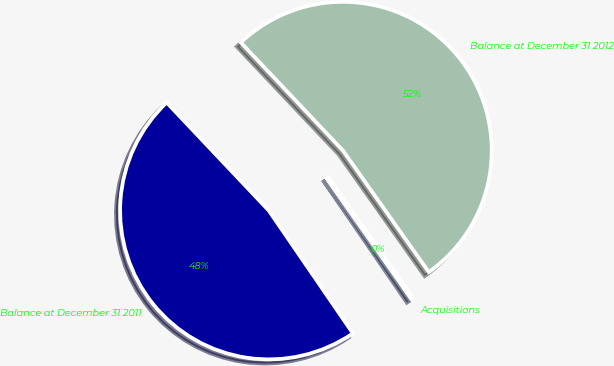Convert chart. <chart><loc_0><loc_0><loc_500><loc_500><pie_chart><fcel>Balance at December 31 2011<fcel>Acquisitions<fcel>Balance at December 31 2012<nl><fcel>47.51%<fcel>0.23%<fcel>52.26%<nl></chart> 